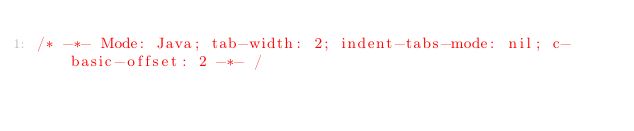<code> <loc_0><loc_0><loc_500><loc_500><_JavaScript_>/* -*- Mode: Java; tab-width: 2; indent-tabs-mode: nil; c-basic-offset: 2 -*- /</code> 